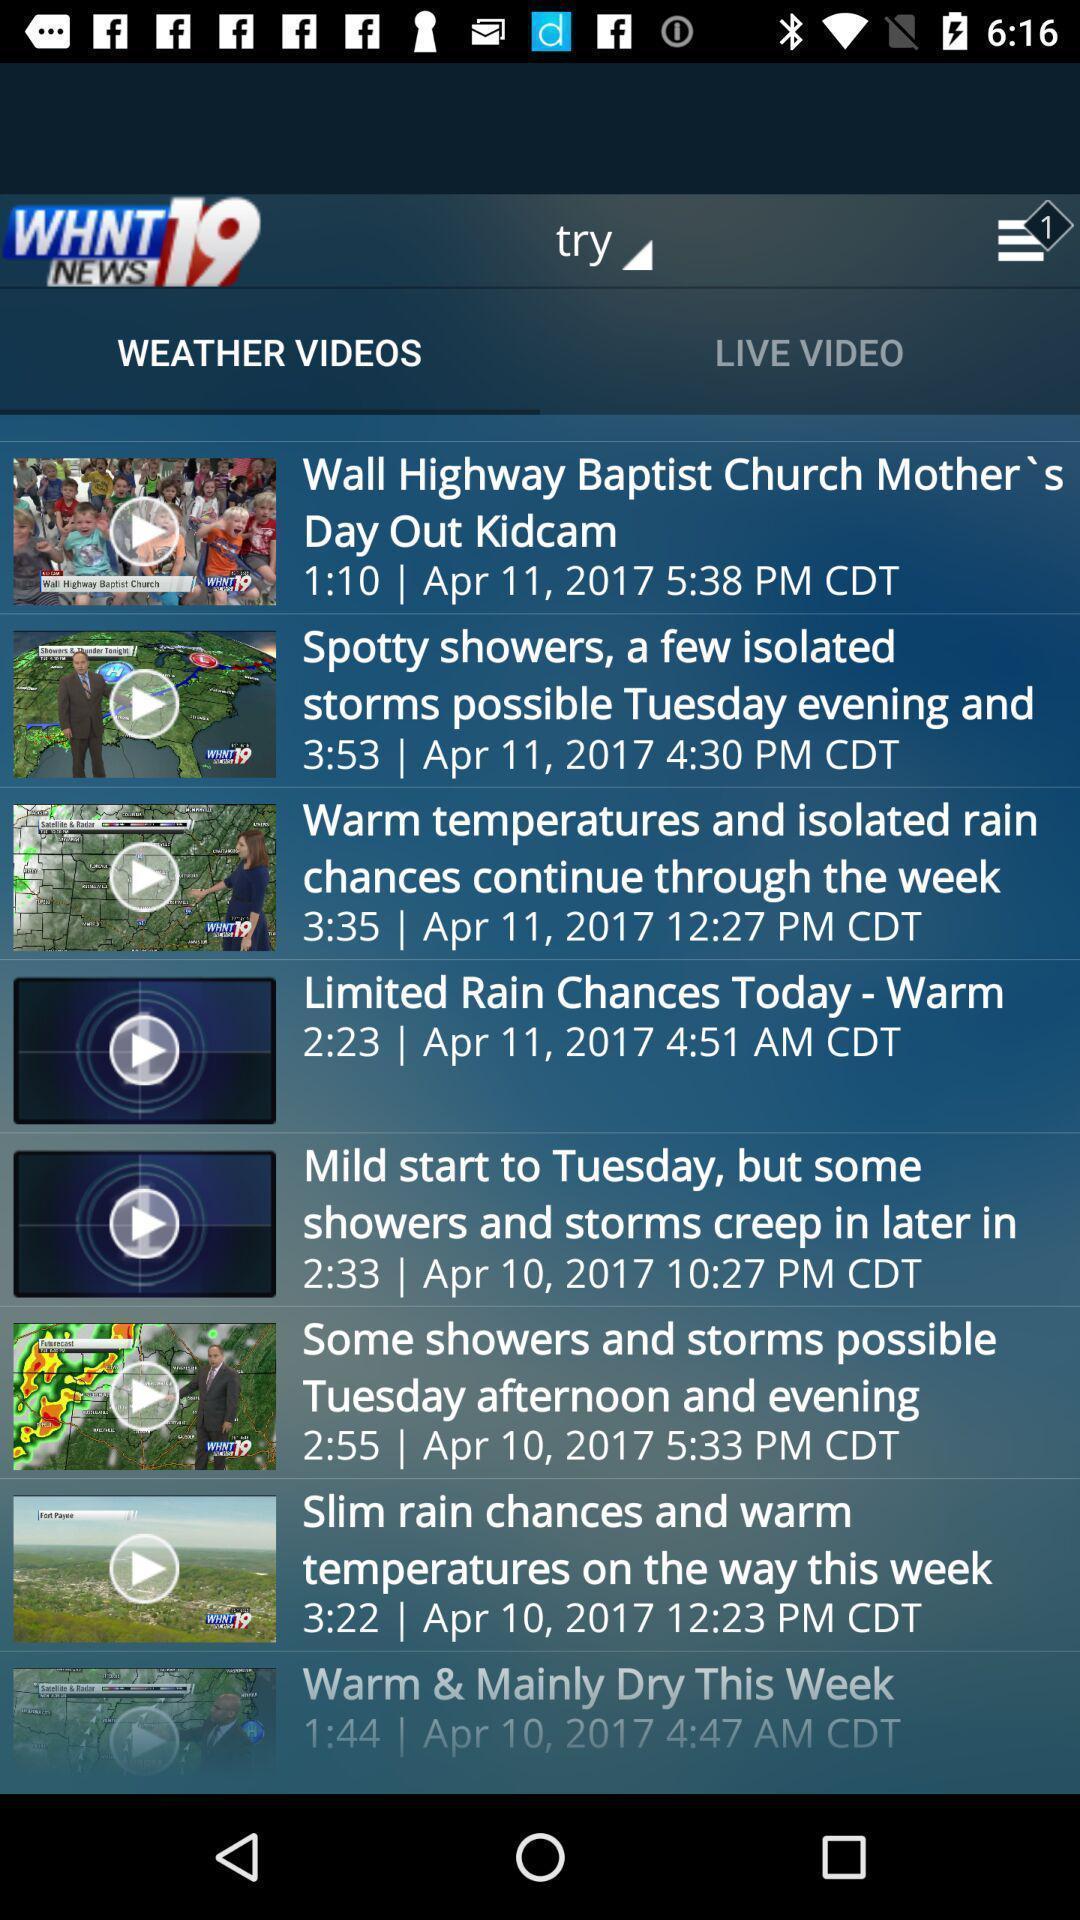What is the overall content of this screenshot? Page of a news app displaying list of videos. 